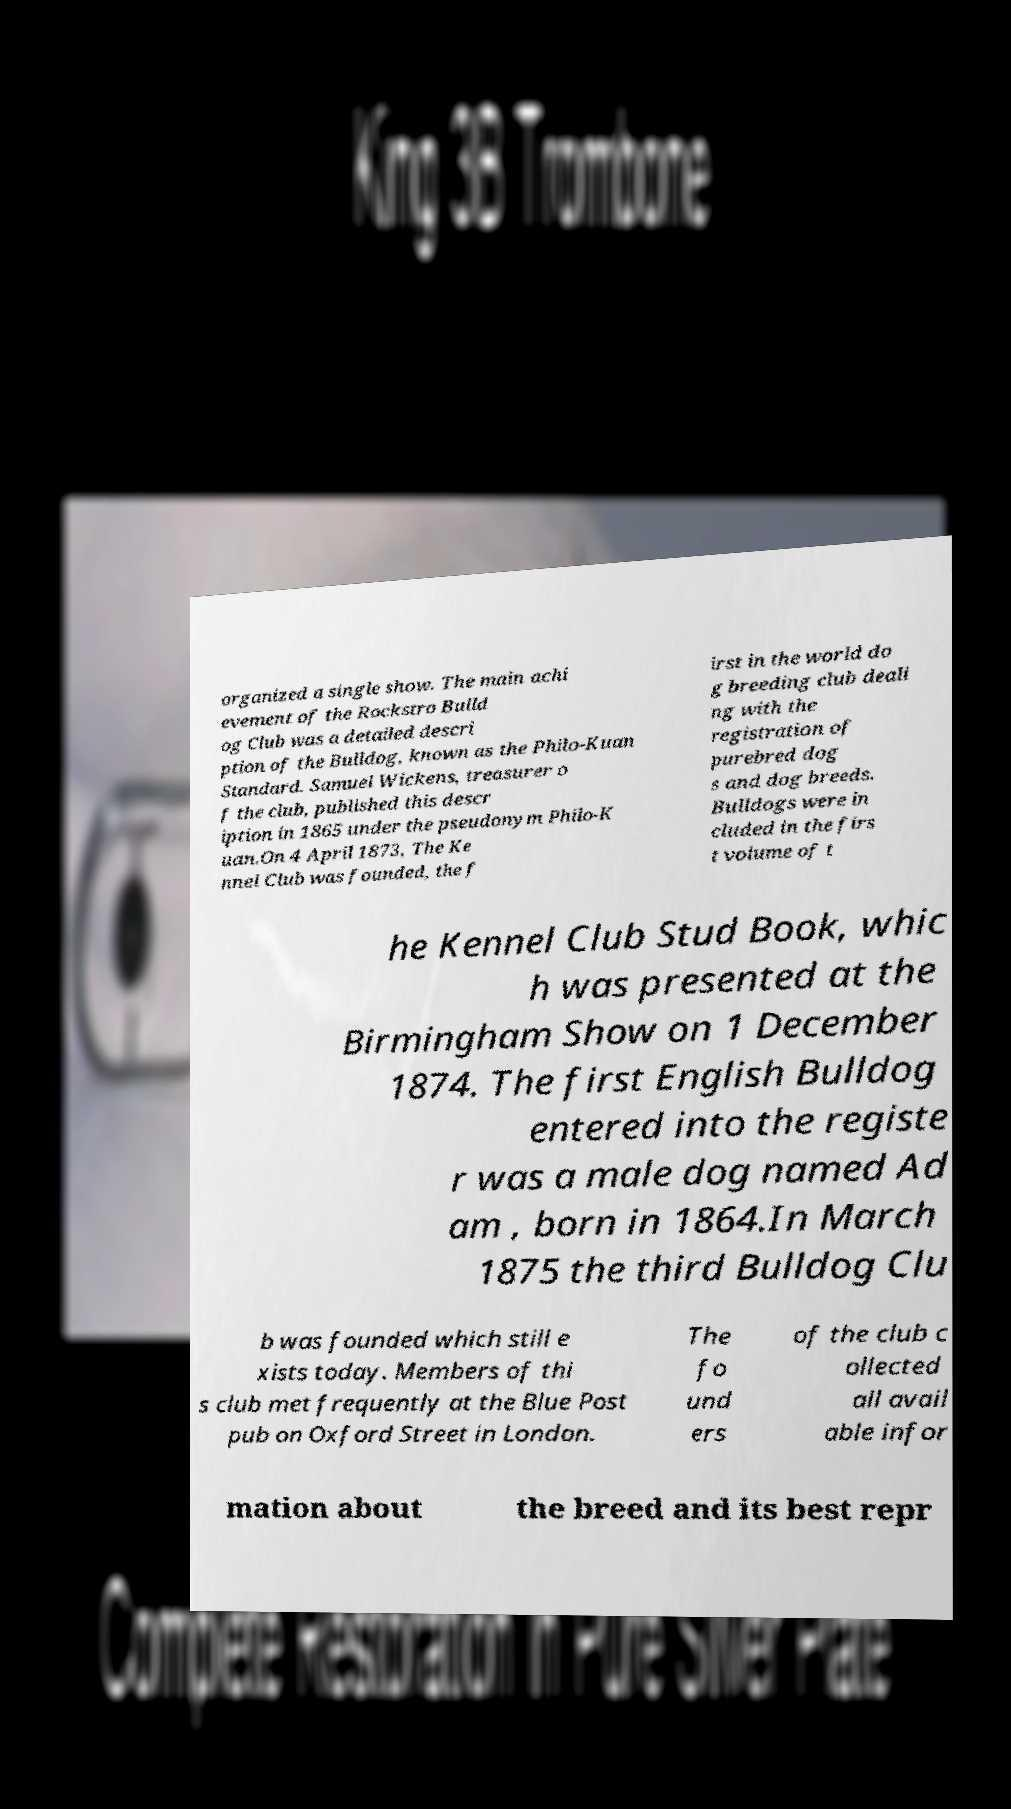What messages or text are displayed in this image? I need them in a readable, typed format. organized a single show. The main achi evement of the Rockstro Bulld og Club was a detailed descri ption of the Bulldog, known as the Philo-Kuan Standard. Samuel Wickens, treasurer o f the club, published this descr iption in 1865 under the pseudonym Philo-K uan.On 4 April 1873, The Ke nnel Club was founded, the f irst in the world do g breeding club deali ng with the registration of purebred dog s and dog breeds. Bulldogs were in cluded in the firs t volume of t he Kennel Club Stud Book, whic h was presented at the Birmingham Show on 1 December 1874. The first English Bulldog entered into the registe r was a male dog named Ad am , born in 1864.In March 1875 the third Bulldog Clu b was founded which still e xists today. Members of thi s club met frequently at the Blue Post pub on Oxford Street in London. The fo und ers of the club c ollected all avail able infor mation about the breed and its best repr 